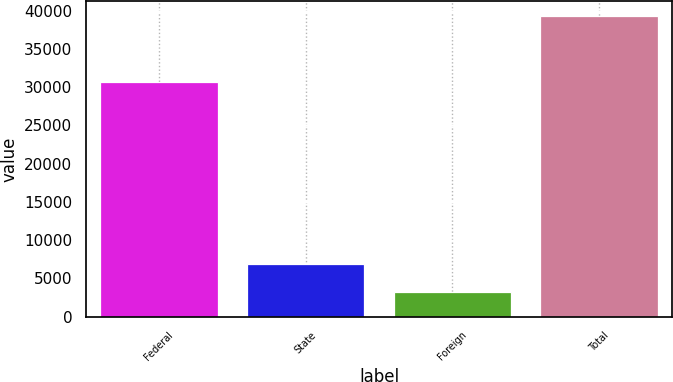Convert chart to OTSL. <chart><loc_0><loc_0><loc_500><loc_500><bar_chart><fcel>Federal<fcel>State<fcel>Foreign<fcel>Total<nl><fcel>30660<fcel>6857.4<fcel>3254<fcel>39288<nl></chart> 